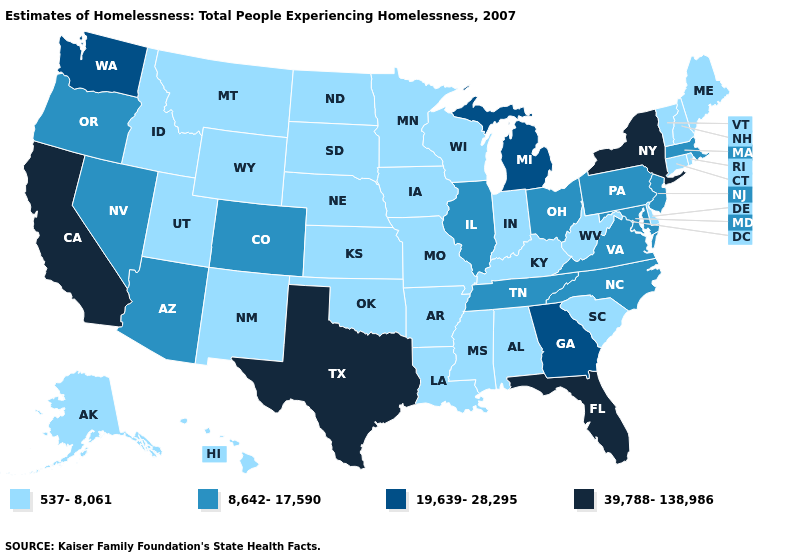What is the value of Louisiana?
Short answer required. 537-8,061. What is the value of Minnesota?
Short answer required. 537-8,061. Name the states that have a value in the range 39,788-138,986?
Concise answer only. California, Florida, New York, Texas. Among the states that border Indiana , which have the lowest value?
Give a very brief answer. Kentucky. Which states have the lowest value in the West?
Quick response, please. Alaska, Hawaii, Idaho, Montana, New Mexico, Utah, Wyoming. Which states hav the highest value in the South?
Keep it brief. Florida, Texas. Does Virginia have the lowest value in the USA?
Give a very brief answer. No. What is the value of Arkansas?
Keep it brief. 537-8,061. Among the states that border Virginia , does Kentucky have the highest value?
Be succinct. No. Which states have the lowest value in the South?
Concise answer only. Alabama, Arkansas, Delaware, Kentucky, Louisiana, Mississippi, Oklahoma, South Carolina, West Virginia. Which states hav the highest value in the South?
Keep it brief. Florida, Texas. Which states have the lowest value in the Northeast?
Answer briefly. Connecticut, Maine, New Hampshire, Rhode Island, Vermont. What is the value of North Carolina?
Concise answer only. 8,642-17,590. What is the lowest value in states that border Georgia?
Short answer required. 537-8,061. Name the states that have a value in the range 19,639-28,295?
Keep it brief. Georgia, Michigan, Washington. 